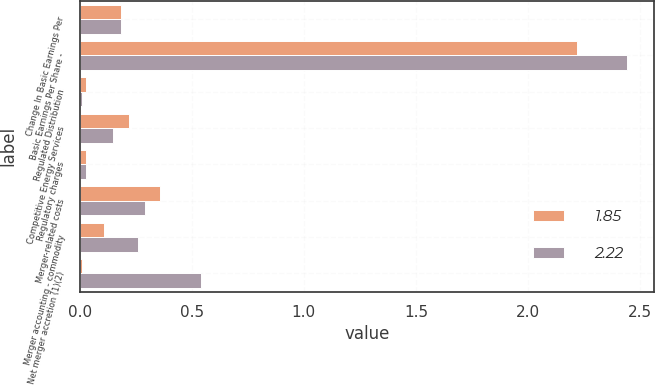<chart> <loc_0><loc_0><loc_500><loc_500><stacked_bar_chart><ecel><fcel>Change In Basic Earnings Per<fcel>Basic Earnings Per Share -<fcel>Regulated Distribution<fcel>Competitive Energy Services<fcel>Regulatory charges<fcel>Merger-related costs<fcel>Merger accounting - commodity<fcel>Net merger accretion (1)(2)<nl><fcel>1.85<fcel>0.185<fcel>2.22<fcel>0.03<fcel>0.22<fcel>0.03<fcel>0.36<fcel>0.11<fcel>0.01<nl><fcel>2.22<fcel>0.185<fcel>2.44<fcel>0.01<fcel>0.15<fcel>0.03<fcel>0.29<fcel>0.26<fcel>0.54<nl></chart> 